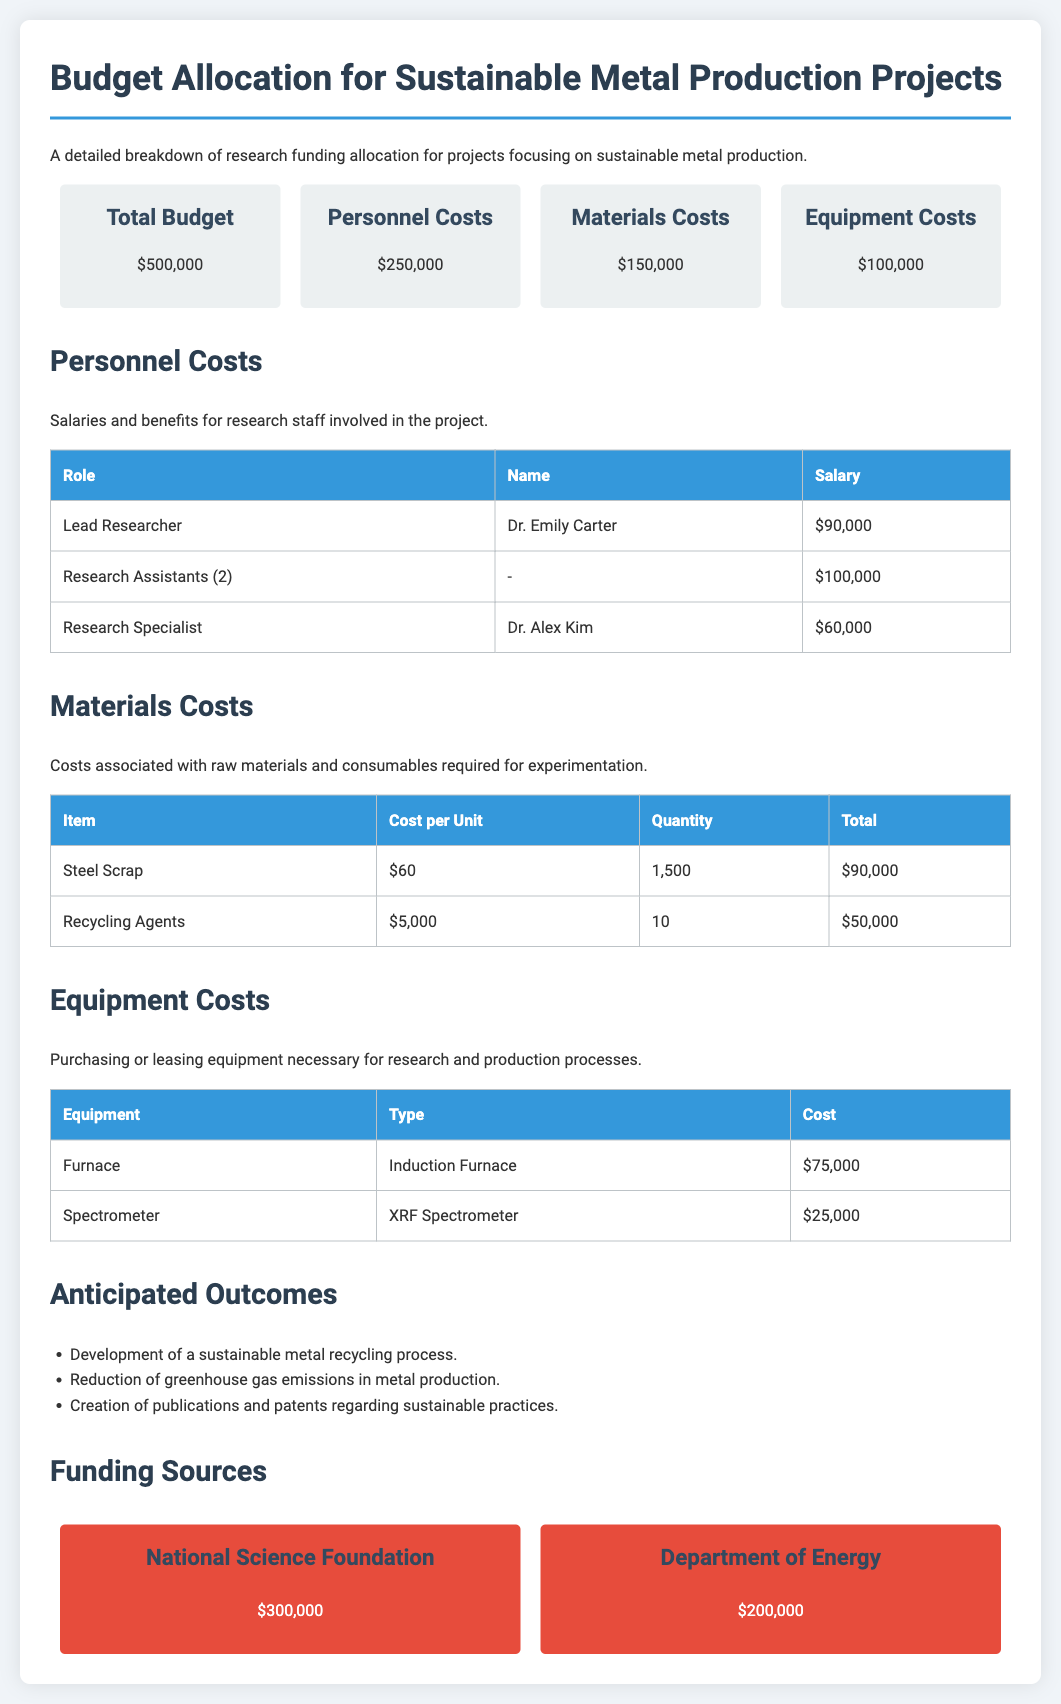what is the total budget? The total budget for the sustainable metal production projects is presented clearly in the document.
Answer: $500,000 who is the lead researcher? The document specifies the name of the lead researcher associated with personnel costs.
Answer: Dr. Emily Carter how much is allocated for materials costs? The document provides a distinct breakdown of costs, particularly highlighting the amount set aside for materials.
Answer: $150,000 what type of equipment is the furnace? The specific type of furnace equipment necessary for the project is detailed in the equipment costs section.
Answer: Induction Furnace what is the total cost for steel scrap? The total costs associated with the quantity of steel scrap required for the project are detailed in the materials costs section.
Answer: $90,000 how many research assistants are included in personnel costs? The personnel costs section mentions the number of research assistants explicitly.
Answer: 2 what is the funding source from the Department of Energy? The document lists various funding sources, including their corresponding amounts, one of which is from the Department of Energy.
Answer: $200,000 what is the cost of the XRF Spectrometer? The cost of specific equipment, such as the XRF Spectrometer, is clearly indicated in the equipment costs section.
Answer: $25,000 what is the anticipated outcome related to greenhouse gas emissions? The document outlines anticipated outcomes, including specific reductions that the project aims to achieve.
Answer: Reduction of greenhouse gas emissions in metal production 